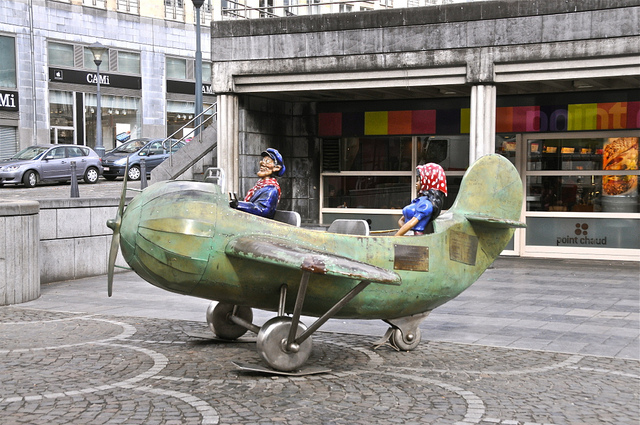Please transcribe the text information in this image. point chaud Mi 